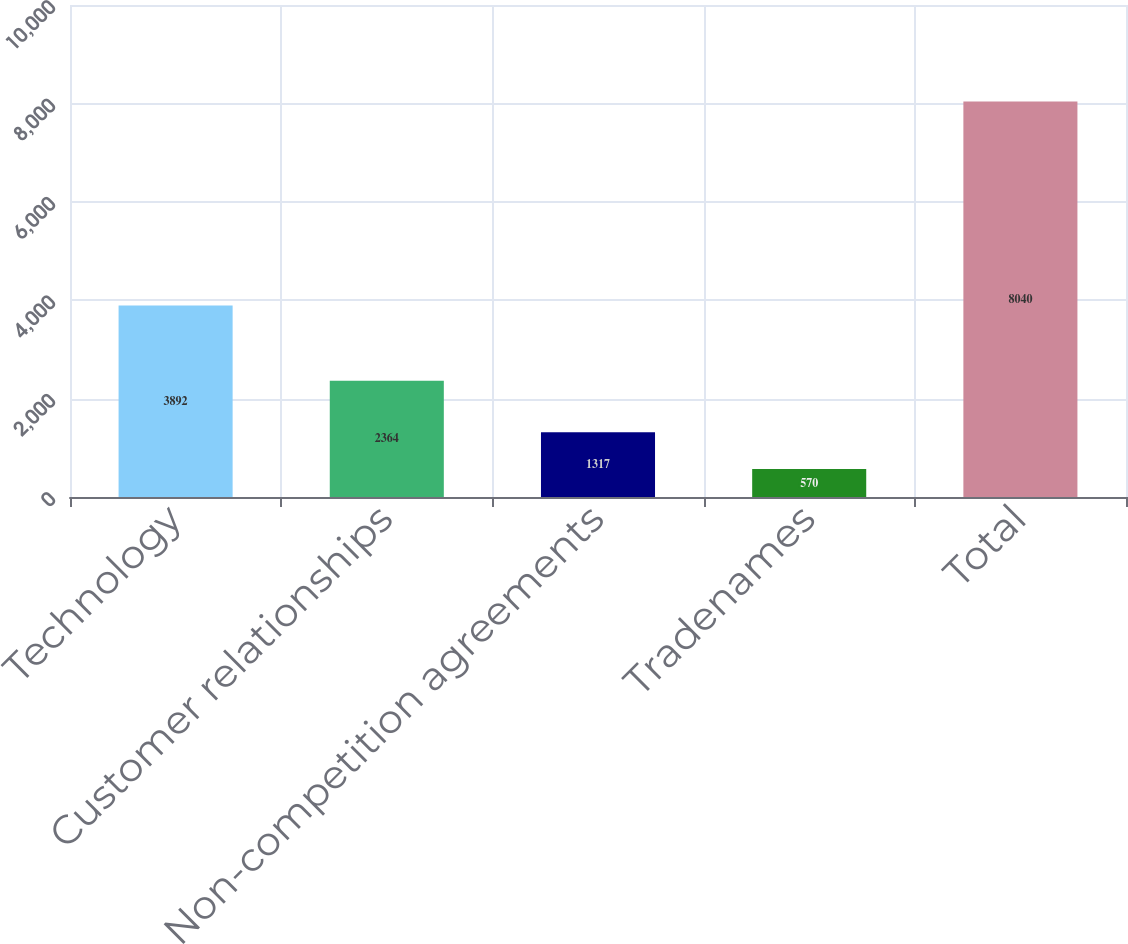Convert chart. <chart><loc_0><loc_0><loc_500><loc_500><bar_chart><fcel>Technology<fcel>Customer relationships<fcel>Non-competition agreements<fcel>Tradenames<fcel>Total<nl><fcel>3892<fcel>2364<fcel>1317<fcel>570<fcel>8040<nl></chart> 